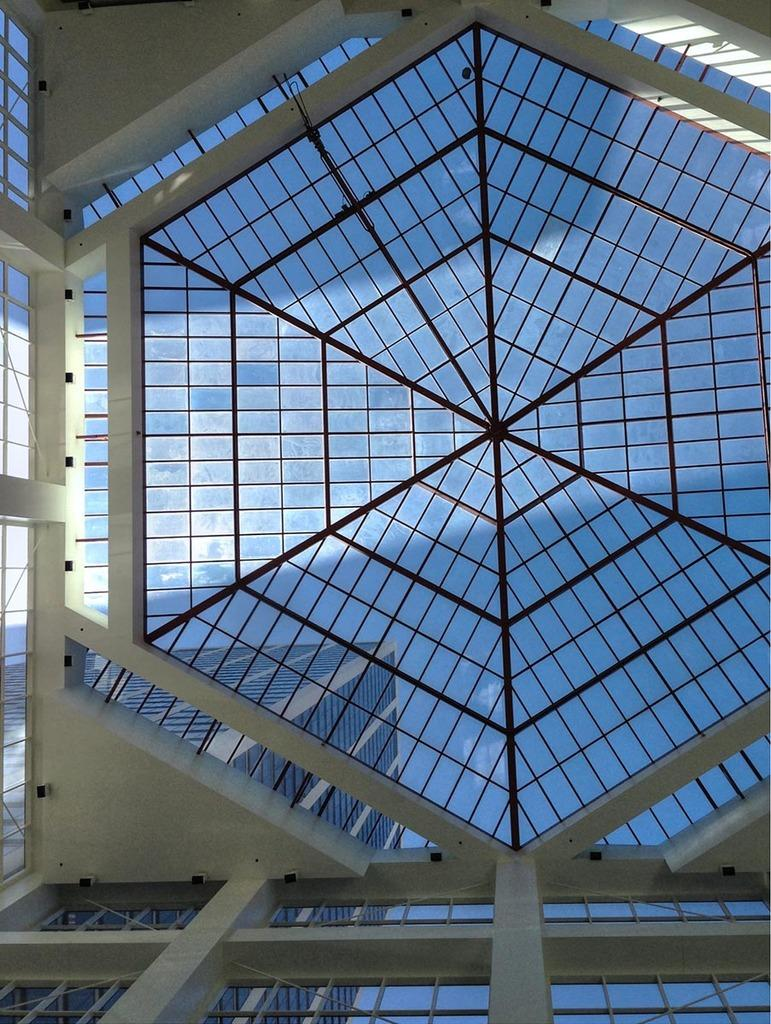What type of construction can be seen in the image? There is a construction made up of glass in the image. What other structures are present in the image? There is a building in the image. What part of the natural environment is visible in the image? The sky is visible in the image. What is the opinion of the cave in the image? There is no cave present in the image, so it is not possible to determine its opinion. 